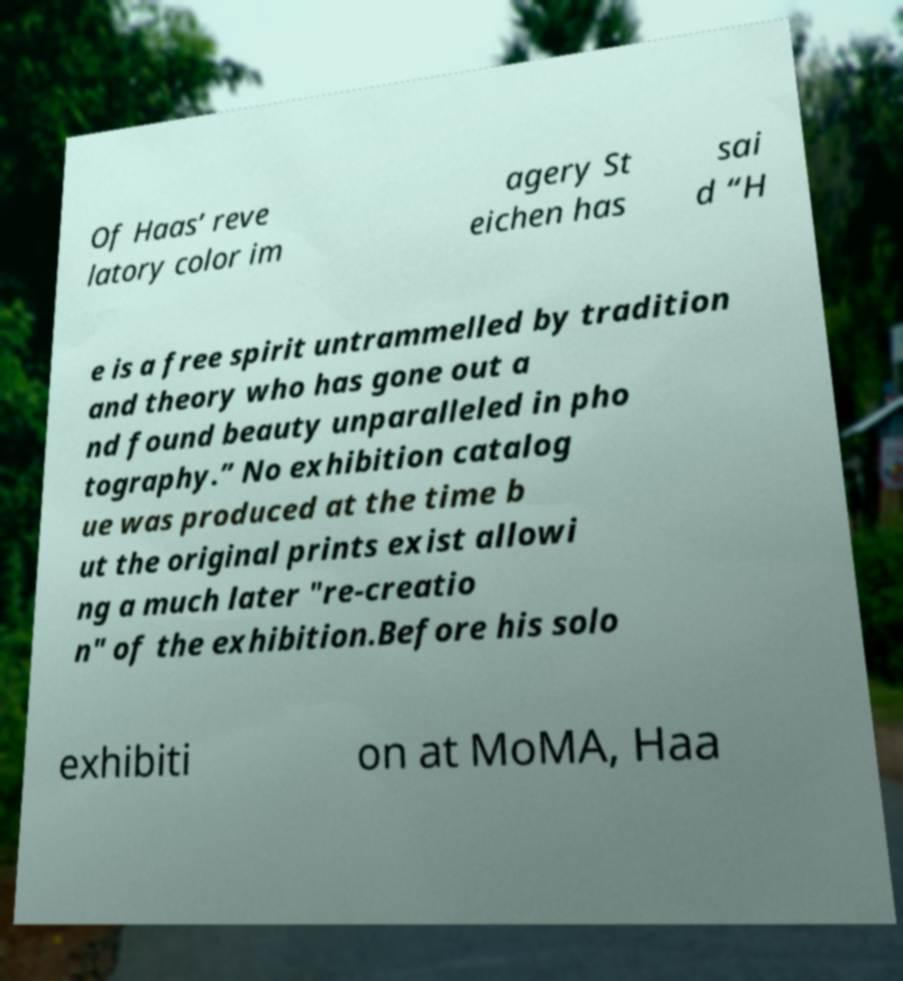For documentation purposes, I need the text within this image transcribed. Could you provide that? Of Haas’ reve latory color im agery St eichen has sai d “H e is a free spirit untrammelled by tradition and theory who has gone out a nd found beauty unparalleled in pho tography.” No exhibition catalog ue was produced at the time b ut the original prints exist allowi ng a much later "re-creatio n" of the exhibition.Before his solo exhibiti on at MoMA, Haa 